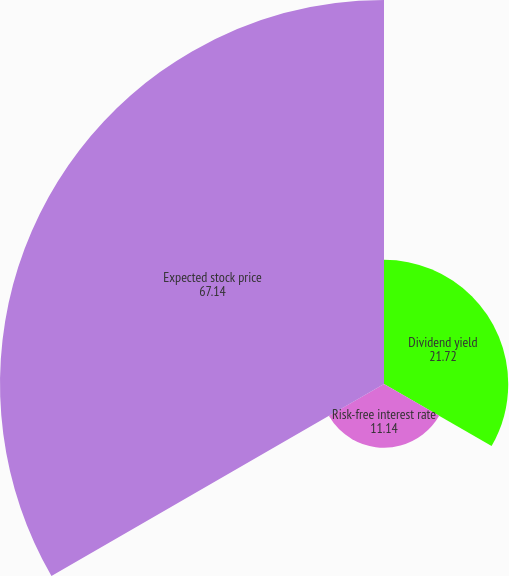Convert chart. <chart><loc_0><loc_0><loc_500><loc_500><pie_chart><fcel>Dividend yield<fcel>Risk-free interest rate<fcel>Expected stock price<nl><fcel>21.72%<fcel>11.14%<fcel>67.14%<nl></chart> 